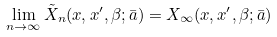<formula> <loc_0><loc_0><loc_500><loc_500>\lim _ { n \to \infty } \tilde { X } _ { n } ( x , x ^ { \prime } , \beta ; \bar { a } ) = X _ { \infty } ( x , x ^ { \prime } , \beta ; \bar { a } )</formula> 